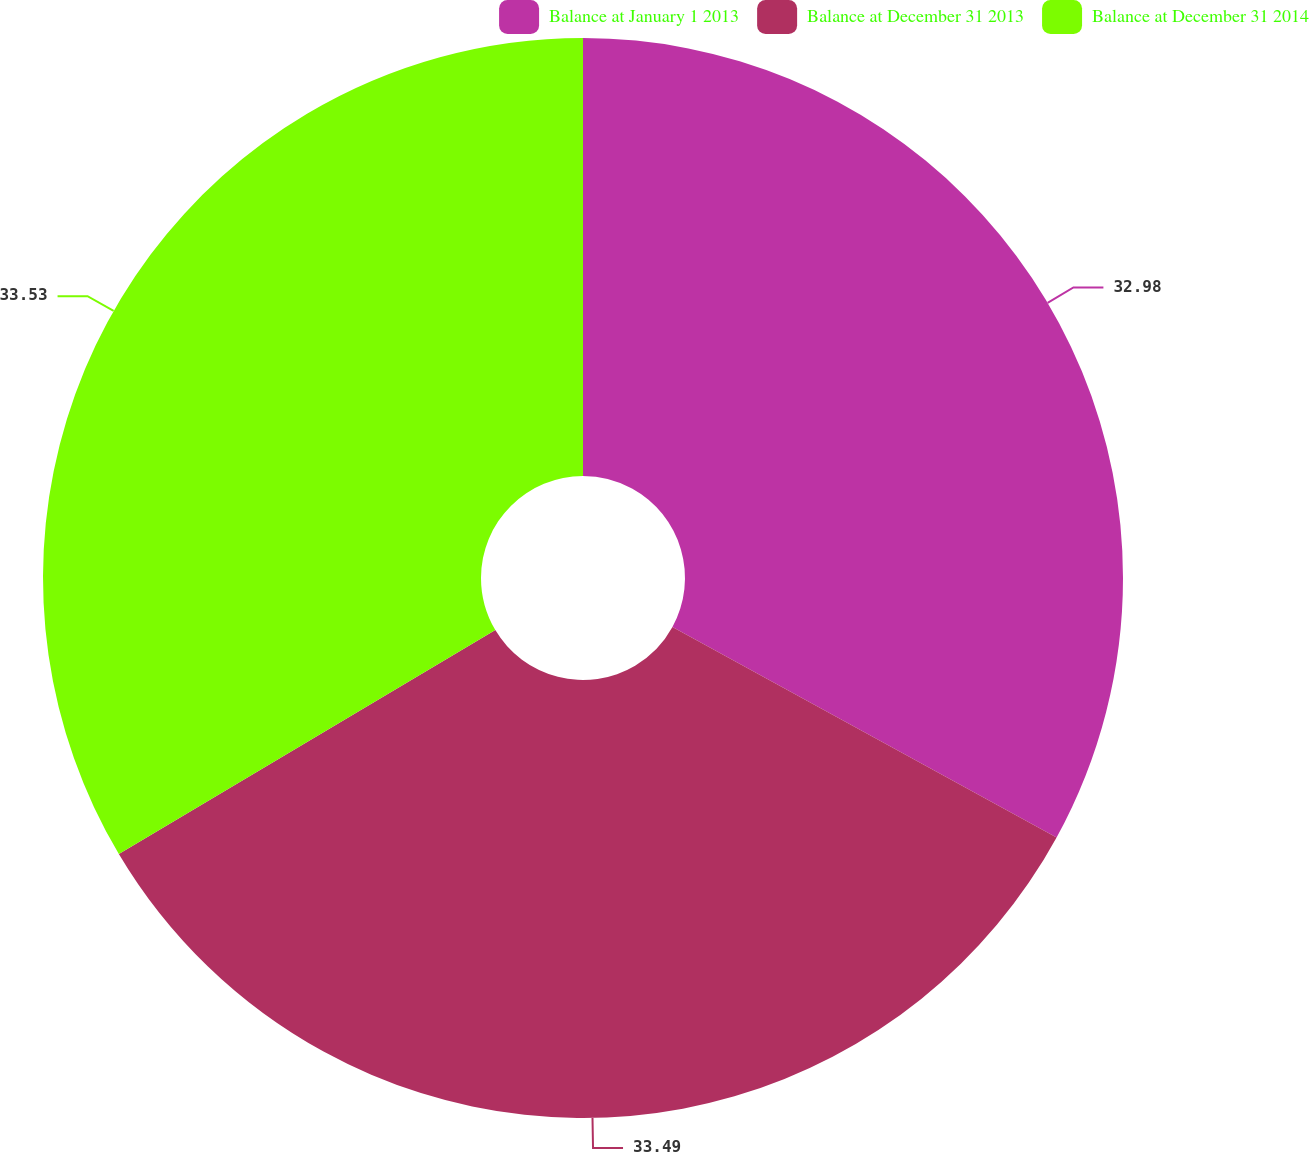Convert chart. <chart><loc_0><loc_0><loc_500><loc_500><pie_chart><fcel>Balance at January 1 2013<fcel>Balance at December 31 2013<fcel>Balance at December 31 2014<nl><fcel>32.98%<fcel>33.49%<fcel>33.54%<nl></chart> 